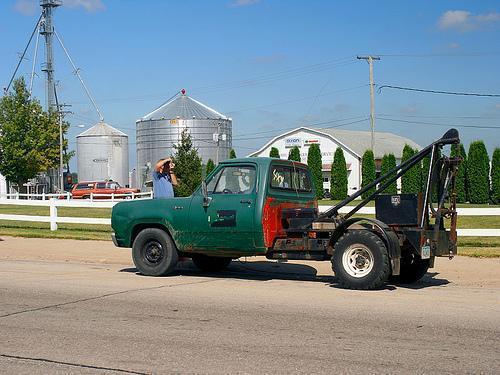How many vehicles are there?
Give a very brief answer. 2. 